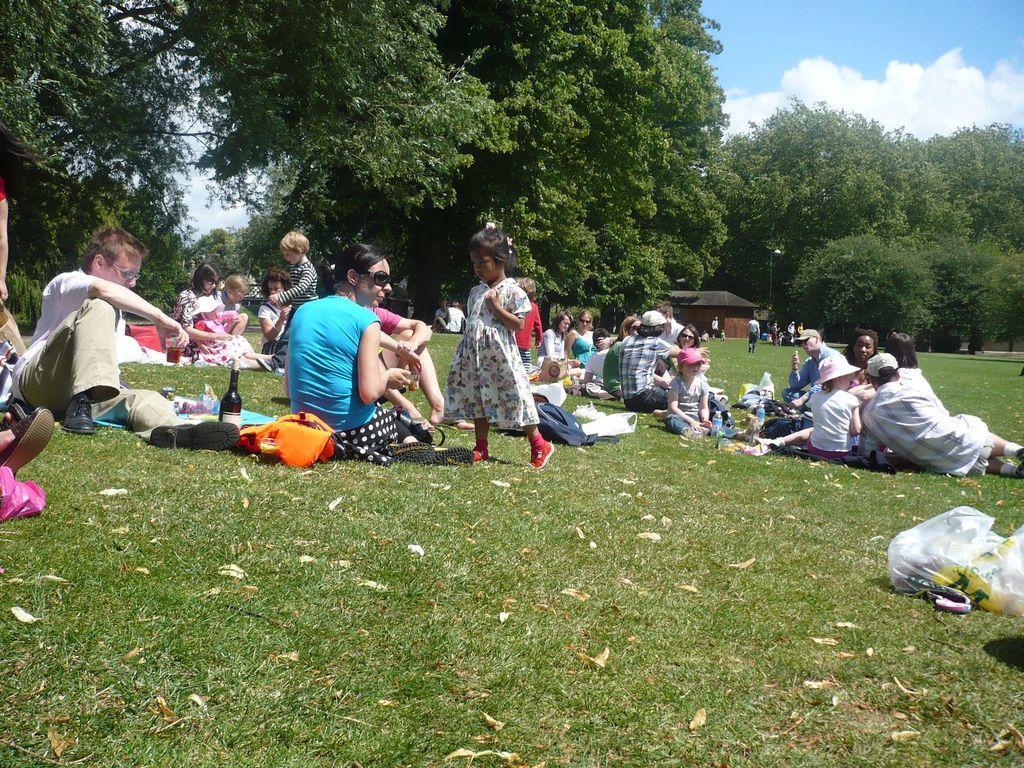Please provide a concise description of this image. In this picture there are group of people sitting. At the back there are group of people standing and there is a house and there are trees. At the top there is sky and there are clouds. At the bottom there are bags and bottles on the grass. 